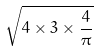Convert formula to latex. <formula><loc_0><loc_0><loc_500><loc_500>\sqrt { 4 \times 3 \times \frac { 4 } { \pi } }</formula> 